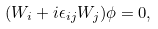<formula> <loc_0><loc_0><loc_500><loc_500>( W _ { i } + i \epsilon _ { i j } W _ { j } ) \phi = 0 ,</formula> 